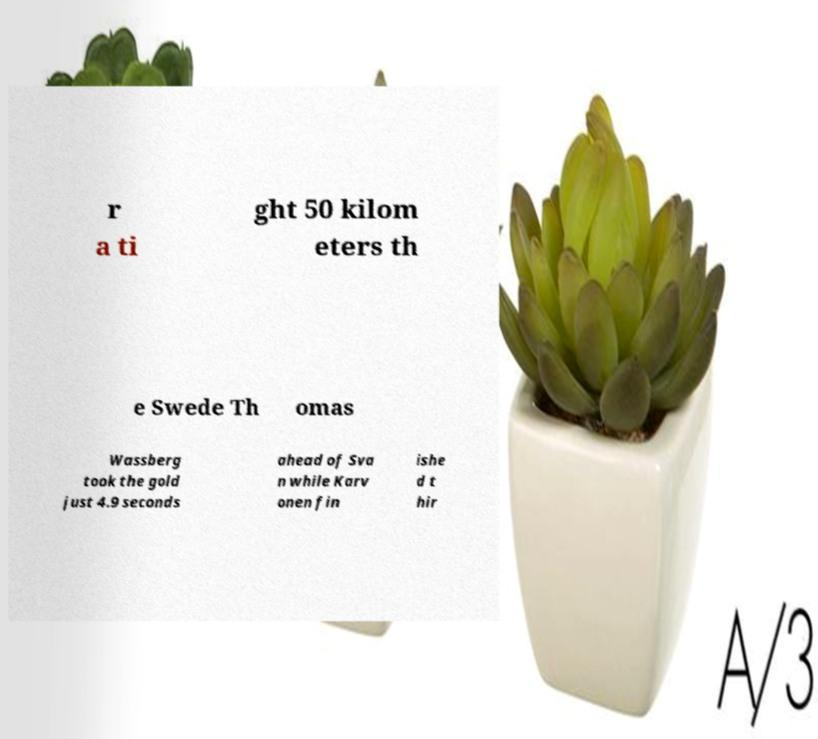Could you assist in decoding the text presented in this image and type it out clearly? r a ti ght 50 kilom eters th e Swede Th omas Wassberg took the gold just 4.9 seconds ahead of Sva n while Karv onen fin ishe d t hir 